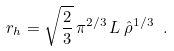<formula> <loc_0><loc_0><loc_500><loc_500>r _ { h } = \sqrt { \frac { 2 } { 3 } } \, \pi ^ { 2 / 3 } \, L \, \hat { \rho } ^ { 1 / 3 } \ .</formula> 